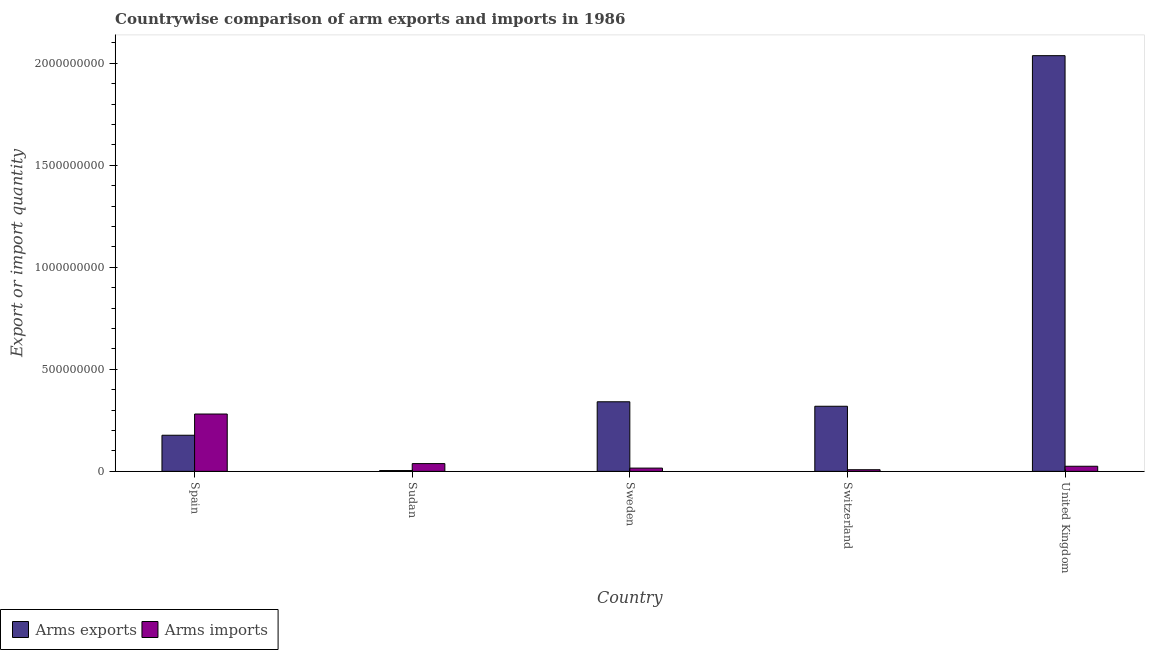How many different coloured bars are there?
Keep it short and to the point. 2. What is the label of the 3rd group of bars from the left?
Offer a terse response. Sweden. In how many cases, is the number of bars for a given country not equal to the number of legend labels?
Keep it short and to the point. 0. What is the arms imports in Sweden?
Make the answer very short. 1.60e+07. Across all countries, what is the maximum arms imports?
Your answer should be compact. 2.81e+08. Across all countries, what is the minimum arms exports?
Ensure brevity in your answer.  4.00e+06. In which country was the arms exports minimum?
Provide a short and direct response. Sudan. What is the total arms exports in the graph?
Your answer should be very brief. 2.88e+09. What is the difference between the arms imports in Sudan and that in Sweden?
Your answer should be very brief. 2.20e+07. What is the difference between the arms exports in Sudan and the arms imports in Switzerland?
Your answer should be very brief. -4.00e+06. What is the average arms imports per country?
Offer a very short reply. 7.36e+07. What is the difference between the arms exports and arms imports in Switzerland?
Your answer should be very brief. 3.11e+08. In how many countries, is the arms exports greater than 1300000000 ?
Offer a very short reply. 1. What is the ratio of the arms exports in Sweden to that in Switzerland?
Provide a short and direct response. 1.07. Is the arms exports in Sweden less than that in Switzerland?
Give a very brief answer. No. Is the difference between the arms exports in Spain and United Kingdom greater than the difference between the arms imports in Spain and United Kingdom?
Provide a short and direct response. No. What is the difference between the highest and the second highest arms exports?
Provide a succinct answer. 1.70e+09. What is the difference between the highest and the lowest arms imports?
Offer a very short reply. 2.73e+08. In how many countries, is the arms imports greater than the average arms imports taken over all countries?
Ensure brevity in your answer.  1. What does the 1st bar from the left in Sweden represents?
Your response must be concise. Arms exports. What does the 1st bar from the right in Switzerland represents?
Offer a terse response. Arms imports. How many bars are there?
Your answer should be very brief. 10. What is the difference between two consecutive major ticks on the Y-axis?
Keep it short and to the point. 5.00e+08. Are the values on the major ticks of Y-axis written in scientific E-notation?
Make the answer very short. No. Does the graph contain any zero values?
Make the answer very short. No. Where does the legend appear in the graph?
Make the answer very short. Bottom left. What is the title of the graph?
Keep it short and to the point. Countrywise comparison of arm exports and imports in 1986. Does "Sanitation services" appear as one of the legend labels in the graph?
Your answer should be compact. No. What is the label or title of the X-axis?
Your answer should be very brief. Country. What is the label or title of the Y-axis?
Your response must be concise. Export or import quantity. What is the Export or import quantity of Arms exports in Spain?
Provide a succinct answer. 1.77e+08. What is the Export or import quantity of Arms imports in Spain?
Keep it short and to the point. 2.81e+08. What is the Export or import quantity in Arms exports in Sudan?
Your answer should be compact. 4.00e+06. What is the Export or import quantity in Arms imports in Sudan?
Give a very brief answer. 3.80e+07. What is the Export or import quantity in Arms exports in Sweden?
Ensure brevity in your answer.  3.41e+08. What is the Export or import quantity of Arms imports in Sweden?
Offer a very short reply. 1.60e+07. What is the Export or import quantity of Arms exports in Switzerland?
Offer a terse response. 3.19e+08. What is the Export or import quantity in Arms imports in Switzerland?
Keep it short and to the point. 8.00e+06. What is the Export or import quantity of Arms exports in United Kingdom?
Your answer should be compact. 2.04e+09. What is the Export or import quantity in Arms imports in United Kingdom?
Your answer should be very brief. 2.50e+07. Across all countries, what is the maximum Export or import quantity in Arms exports?
Give a very brief answer. 2.04e+09. Across all countries, what is the maximum Export or import quantity in Arms imports?
Make the answer very short. 2.81e+08. Across all countries, what is the minimum Export or import quantity in Arms imports?
Provide a short and direct response. 8.00e+06. What is the total Export or import quantity of Arms exports in the graph?
Offer a very short reply. 2.88e+09. What is the total Export or import quantity of Arms imports in the graph?
Make the answer very short. 3.68e+08. What is the difference between the Export or import quantity of Arms exports in Spain and that in Sudan?
Make the answer very short. 1.73e+08. What is the difference between the Export or import quantity in Arms imports in Spain and that in Sudan?
Ensure brevity in your answer.  2.43e+08. What is the difference between the Export or import quantity of Arms exports in Spain and that in Sweden?
Your response must be concise. -1.64e+08. What is the difference between the Export or import quantity in Arms imports in Spain and that in Sweden?
Offer a very short reply. 2.65e+08. What is the difference between the Export or import quantity of Arms exports in Spain and that in Switzerland?
Provide a succinct answer. -1.42e+08. What is the difference between the Export or import quantity of Arms imports in Spain and that in Switzerland?
Your answer should be compact. 2.73e+08. What is the difference between the Export or import quantity in Arms exports in Spain and that in United Kingdom?
Keep it short and to the point. -1.86e+09. What is the difference between the Export or import quantity in Arms imports in Spain and that in United Kingdom?
Your answer should be very brief. 2.56e+08. What is the difference between the Export or import quantity of Arms exports in Sudan and that in Sweden?
Ensure brevity in your answer.  -3.37e+08. What is the difference between the Export or import quantity in Arms imports in Sudan and that in Sweden?
Make the answer very short. 2.20e+07. What is the difference between the Export or import quantity of Arms exports in Sudan and that in Switzerland?
Your answer should be very brief. -3.15e+08. What is the difference between the Export or import quantity in Arms imports in Sudan and that in Switzerland?
Make the answer very short. 3.00e+07. What is the difference between the Export or import quantity of Arms exports in Sudan and that in United Kingdom?
Your answer should be very brief. -2.03e+09. What is the difference between the Export or import quantity of Arms imports in Sudan and that in United Kingdom?
Your answer should be compact. 1.30e+07. What is the difference between the Export or import quantity in Arms exports in Sweden and that in Switzerland?
Make the answer very short. 2.20e+07. What is the difference between the Export or import quantity of Arms exports in Sweden and that in United Kingdom?
Your response must be concise. -1.70e+09. What is the difference between the Export or import quantity in Arms imports in Sweden and that in United Kingdom?
Ensure brevity in your answer.  -9.00e+06. What is the difference between the Export or import quantity of Arms exports in Switzerland and that in United Kingdom?
Offer a very short reply. -1.72e+09. What is the difference between the Export or import quantity in Arms imports in Switzerland and that in United Kingdom?
Make the answer very short. -1.70e+07. What is the difference between the Export or import quantity of Arms exports in Spain and the Export or import quantity of Arms imports in Sudan?
Your response must be concise. 1.39e+08. What is the difference between the Export or import quantity of Arms exports in Spain and the Export or import quantity of Arms imports in Sweden?
Your response must be concise. 1.61e+08. What is the difference between the Export or import quantity of Arms exports in Spain and the Export or import quantity of Arms imports in Switzerland?
Offer a terse response. 1.69e+08. What is the difference between the Export or import quantity of Arms exports in Spain and the Export or import quantity of Arms imports in United Kingdom?
Keep it short and to the point. 1.52e+08. What is the difference between the Export or import quantity of Arms exports in Sudan and the Export or import quantity of Arms imports in Sweden?
Make the answer very short. -1.20e+07. What is the difference between the Export or import quantity in Arms exports in Sudan and the Export or import quantity in Arms imports in United Kingdom?
Offer a very short reply. -2.10e+07. What is the difference between the Export or import quantity in Arms exports in Sweden and the Export or import quantity in Arms imports in Switzerland?
Your answer should be very brief. 3.33e+08. What is the difference between the Export or import quantity in Arms exports in Sweden and the Export or import quantity in Arms imports in United Kingdom?
Provide a short and direct response. 3.16e+08. What is the difference between the Export or import quantity of Arms exports in Switzerland and the Export or import quantity of Arms imports in United Kingdom?
Give a very brief answer. 2.94e+08. What is the average Export or import quantity in Arms exports per country?
Give a very brief answer. 5.76e+08. What is the average Export or import quantity of Arms imports per country?
Provide a succinct answer. 7.36e+07. What is the difference between the Export or import quantity of Arms exports and Export or import quantity of Arms imports in Spain?
Provide a succinct answer. -1.04e+08. What is the difference between the Export or import quantity in Arms exports and Export or import quantity in Arms imports in Sudan?
Provide a short and direct response. -3.40e+07. What is the difference between the Export or import quantity in Arms exports and Export or import quantity in Arms imports in Sweden?
Your response must be concise. 3.25e+08. What is the difference between the Export or import quantity of Arms exports and Export or import quantity of Arms imports in Switzerland?
Give a very brief answer. 3.11e+08. What is the difference between the Export or import quantity of Arms exports and Export or import quantity of Arms imports in United Kingdom?
Your answer should be compact. 2.01e+09. What is the ratio of the Export or import quantity in Arms exports in Spain to that in Sudan?
Ensure brevity in your answer.  44.25. What is the ratio of the Export or import quantity of Arms imports in Spain to that in Sudan?
Ensure brevity in your answer.  7.39. What is the ratio of the Export or import quantity of Arms exports in Spain to that in Sweden?
Your response must be concise. 0.52. What is the ratio of the Export or import quantity in Arms imports in Spain to that in Sweden?
Your response must be concise. 17.56. What is the ratio of the Export or import quantity of Arms exports in Spain to that in Switzerland?
Offer a very short reply. 0.55. What is the ratio of the Export or import quantity of Arms imports in Spain to that in Switzerland?
Your answer should be compact. 35.12. What is the ratio of the Export or import quantity in Arms exports in Spain to that in United Kingdom?
Make the answer very short. 0.09. What is the ratio of the Export or import quantity of Arms imports in Spain to that in United Kingdom?
Your answer should be very brief. 11.24. What is the ratio of the Export or import quantity of Arms exports in Sudan to that in Sweden?
Give a very brief answer. 0.01. What is the ratio of the Export or import quantity of Arms imports in Sudan to that in Sweden?
Offer a very short reply. 2.38. What is the ratio of the Export or import quantity of Arms exports in Sudan to that in Switzerland?
Your response must be concise. 0.01. What is the ratio of the Export or import quantity of Arms imports in Sudan to that in Switzerland?
Give a very brief answer. 4.75. What is the ratio of the Export or import quantity in Arms exports in Sudan to that in United Kingdom?
Make the answer very short. 0. What is the ratio of the Export or import quantity in Arms imports in Sudan to that in United Kingdom?
Keep it short and to the point. 1.52. What is the ratio of the Export or import quantity of Arms exports in Sweden to that in Switzerland?
Give a very brief answer. 1.07. What is the ratio of the Export or import quantity of Arms imports in Sweden to that in Switzerland?
Give a very brief answer. 2. What is the ratio of the Export or import quantity of Arms exports in Sweden to that in United Kingdom?
Offer a terse response. 0.17. What is the ratio of the Export or import quantity in Arms imports in Sweden to that in United Kingdom?
Offer a terse response. 0.64. What is the ratio of the Export or import quantity in Arms exports in Switzerland to that in United Kingdom?
Make the answer very short. 0.16. What is the ratio of the Export or import quantity of Arms imports in Switzerland to that in United Kingdom?
Ensure brevity in your answer.  0.32. What is the difference between the highest and the second highest Export or import quantity of Arms exports?
Make the answer very short. 1.70e+09. What is the difference between the highest and the second highest Export or import quantity of Arms imports?
Your answer should be very brief. 2.43e+08. What is the difference between the highest and the lowest Export or import quantity in Arms exports?
Your response must be concise. 2.03e+09. What is the difference between the highest and the lowest Export or import quantity in Arms imports?
Provide a succinct answer. 2.73e+08. 